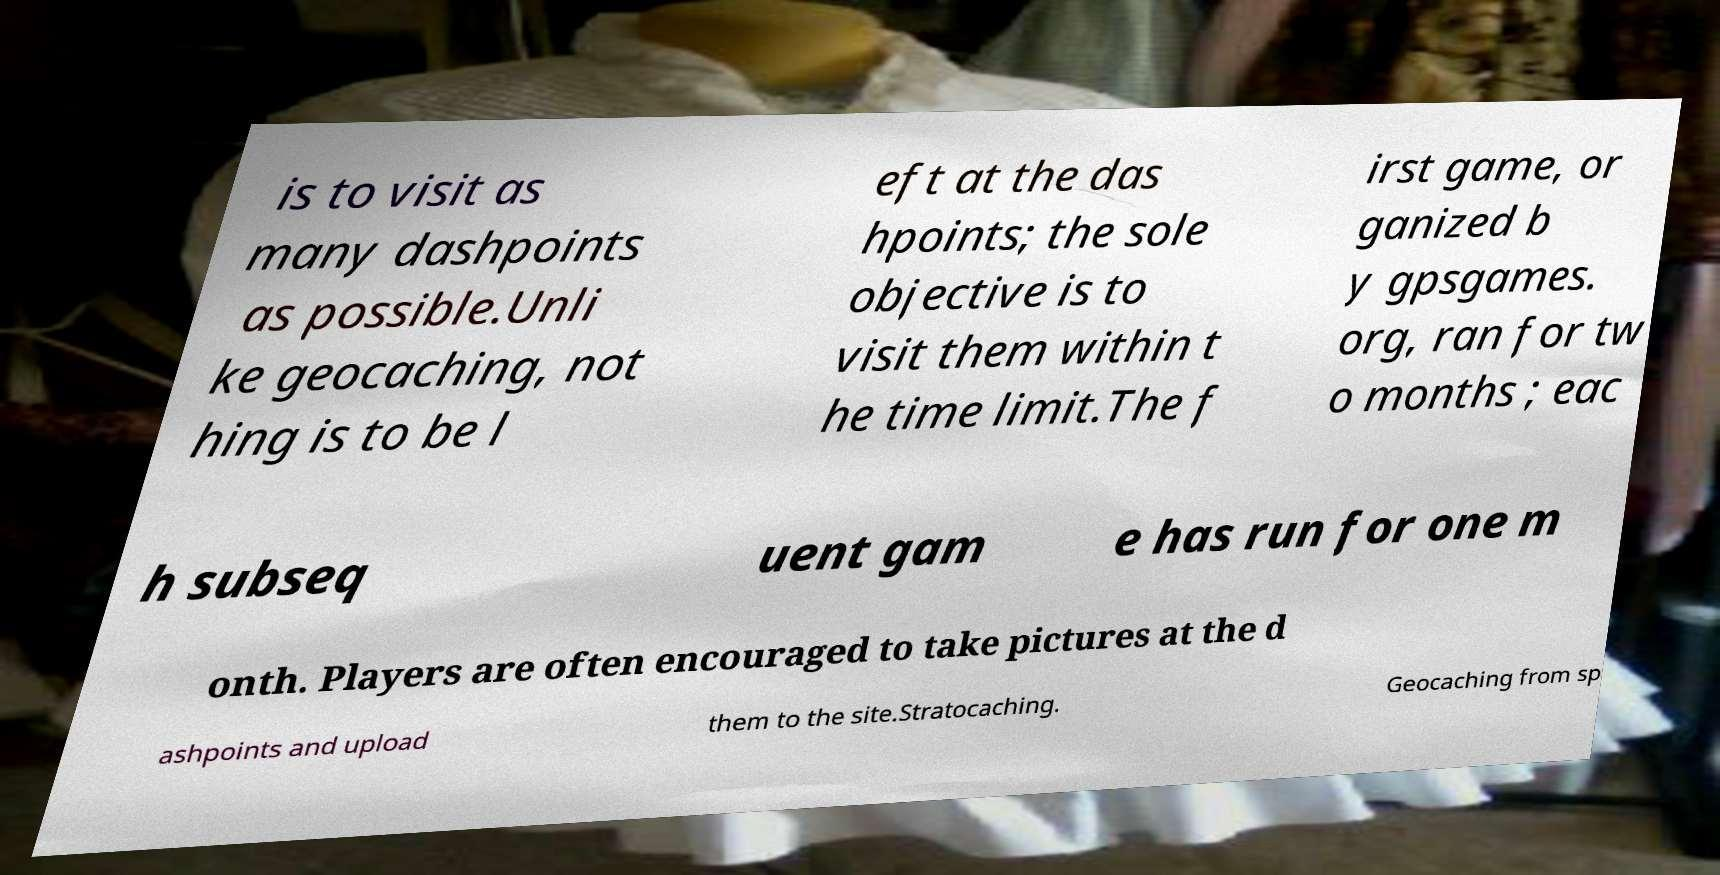What messages or text are displayed in this image? I need them in a readable, typed format. is to visit as many dashpoints as possible.Unli ke geocaching, not hing is to be l eft at the das hpoints; the sole objective is to visit them within t he time limit.The f irst game, or ganized b y gpsgames. org, ran for tw o months ; eac h subseq uent gam e has run for one m onth. Players are often encouraged to take pictures at the d ashpoints and upload them to the site.Stratocaching. Geocaching from sp 